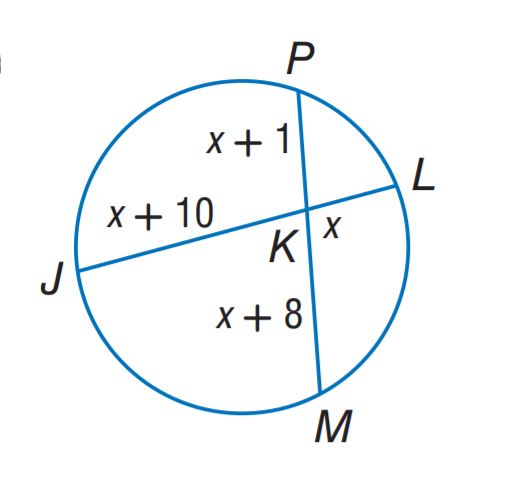Question: Find x.
Choices:
A. 7
B. 8
C. 9
D. 10
Answer with the letter. Answer: B 